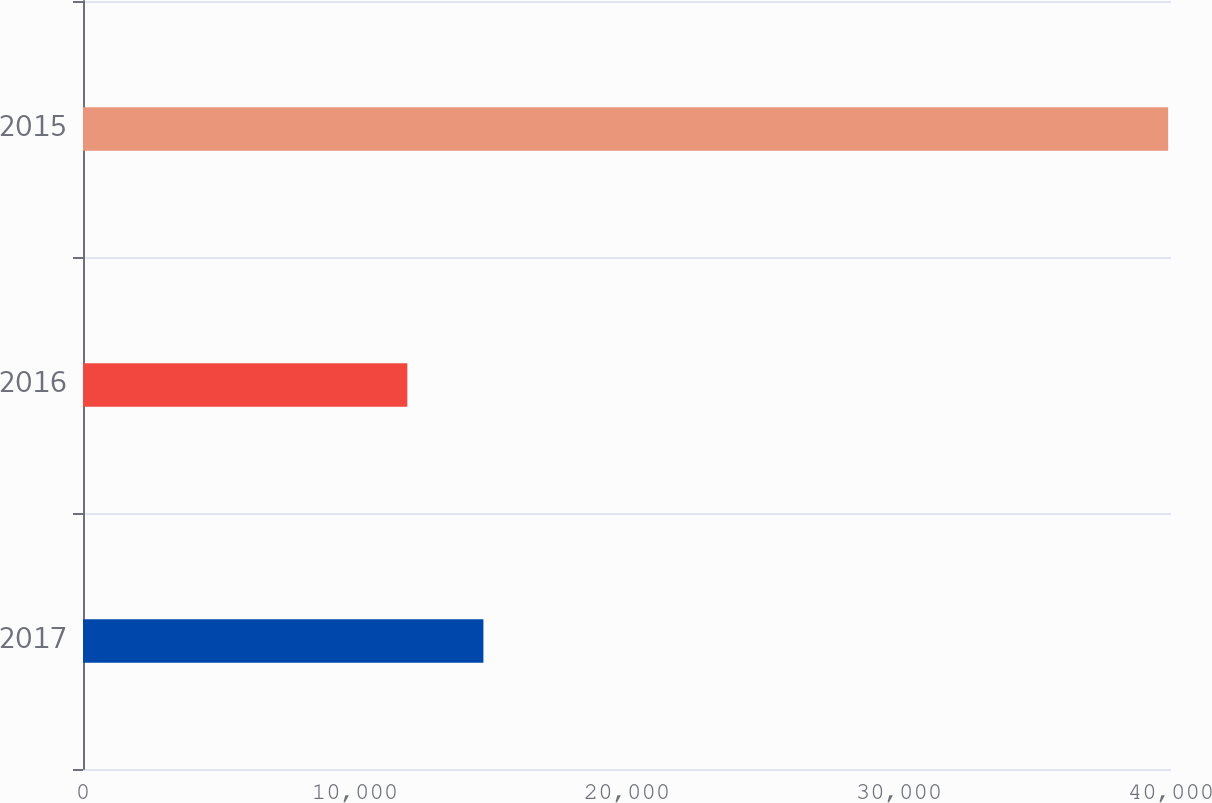Convert chart to OTSL. <chart><loc_0><loc_0><loc_500><loc_500><bar_chart><fcel>2017<fcel>2016<fcel>2015<nl><fcel>14721.1<fcel>11924<fcel>39895<nl></chart> 